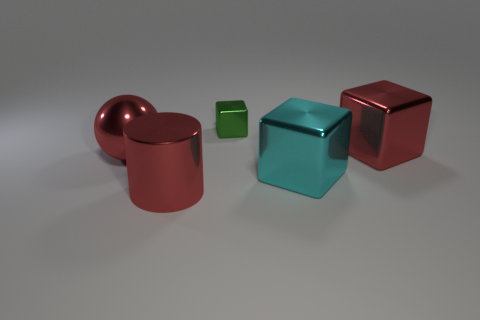Add 4 tiny green shiny blocks. How many objects exist? 9 Subtract all spheres. How many objects are left? 4 Add 5 large red shiny cylinders. How many large red shiny cylinders exist? 6 Subtract 0 purple cylinders. How many objects are left? 5 Subtract all tiny green metallic objects. Subtract all big blocks. How many objects are left? 2 Add 4 big cubes. How many big cubes are left? 6 